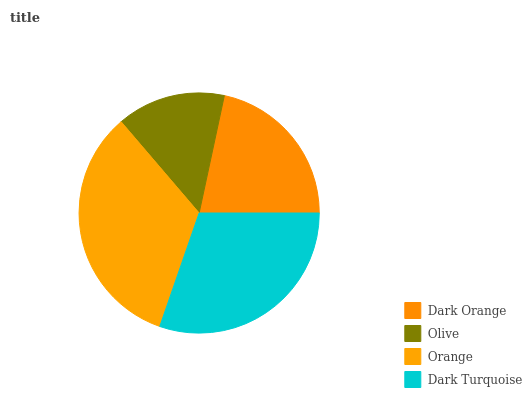Is Olive the minimum?
Answer yes or no. Yes. Is Orange the maximum?
Answer yes or no. Yes. Is Orange the minimum?
Answer yes or no. No. Is Olive the maximum?
Answer yes or no. No. Is Orange greater than Olive?
Answer yes or no. Yes. Is Olive less than Orange?
Answer yes or no. Yes. Is Olive greater than Orange?
Answer yes or no. No. Is Orange less than Olive?
Answer yes or no. No. Is Dark Turquoise the high median?
Answer yes or no. Yes. Is Dark Orange the low median?
Answer yes or no. Yes. Is Olive the high median?
Answer yes or no. No. Is Orange the low median?
Answer yes or no. No. 